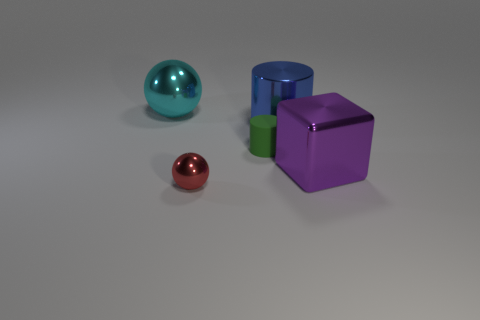What number of other things are there of the same size as the green rubber cylinder?
Make the answer very short. 1. What is the shape of the cyan object?
Your response must be concise. Sphere. What is the material of the sphere behind the tiny cylinder?
Your answer should be very brief. Metal. There is a shiny ball that is behind the shiny sphere that is right of the metallic ball that is behind the large metal block; what is its color?
Your answer should be compact. Cyan. There is a rubber object that is the same size as the red shiny object; what color is it?
Your answer should be compact. Green. What number of metal objects are either purple things or tiny cyan balls?
Offer a terse response. 1. There is a big cylinder that is the same material as the tiny ball; what color is it?
Ensure brevity in your answer.  Blue. What is the material of the tiny red thing that is in front of the big purple metal cube that is to the right of the red ball?
Keep it short and to the point. Metal. What number of things are tiny things on the right side of the red metallic sphere or big shiny things that are to the left of the blue cylinder?
Your response must be concise. 2. How big is the ball left of the shiny ball in front of the big metal object on the left side of the metal cylinder?
Offer a very short reply. Large. 